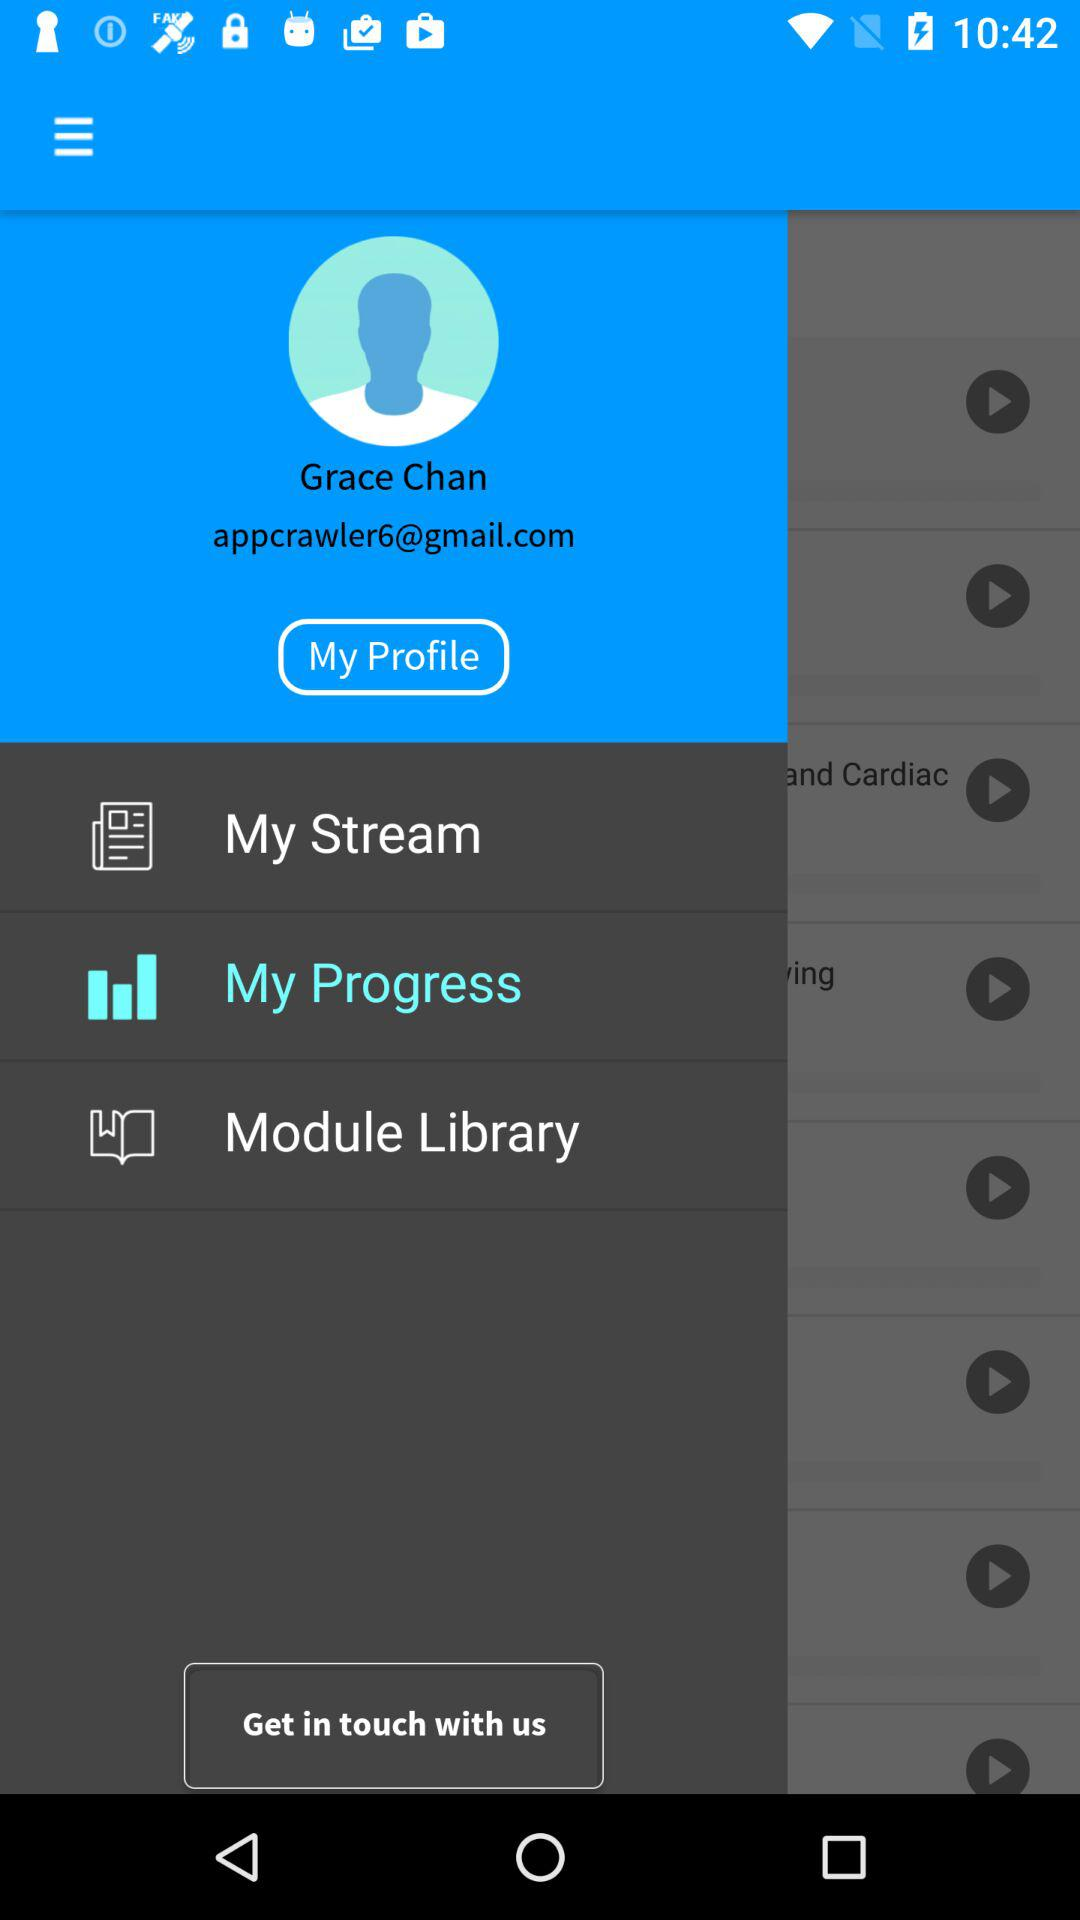What is the name of the user? The name of the user is Grace Chan. 